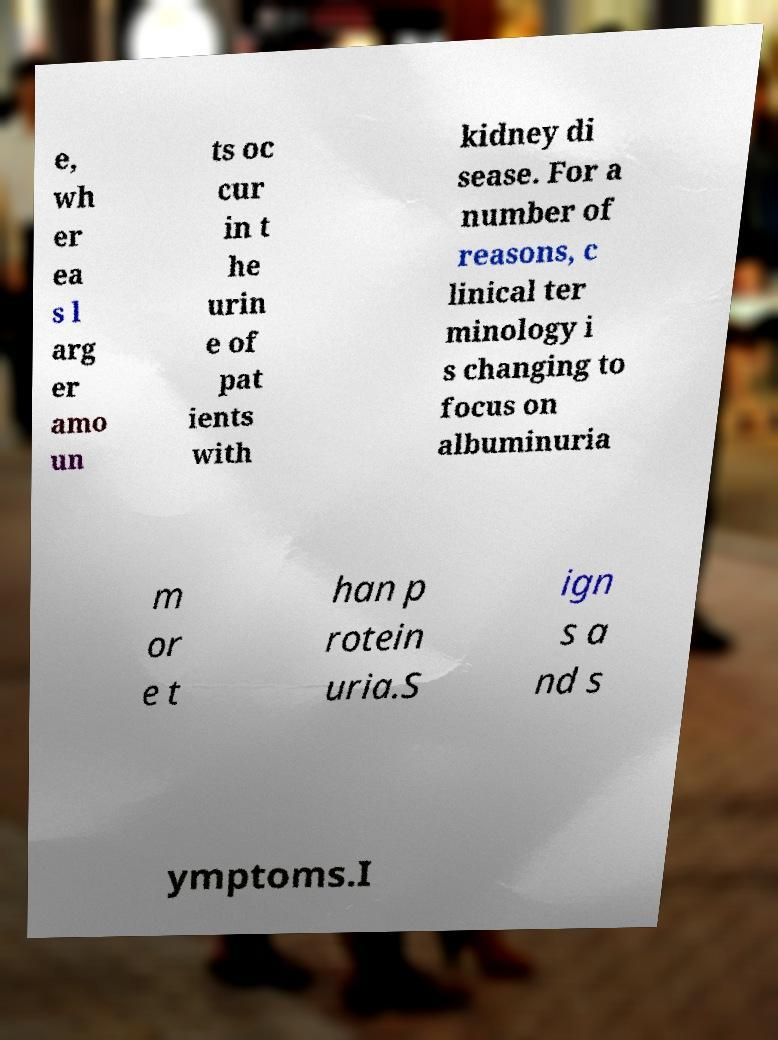I need the written content from this picture converted into text. Can you do that? e, wh er ea s l arg er amo un ts oc cur in t he urin e of pat ients with kidney di sease. For a number of reasons, c linical ter minology i s changing to focus on albuminuria m or e t han p rotein uria.S ign s a nd s ymptoms.I 